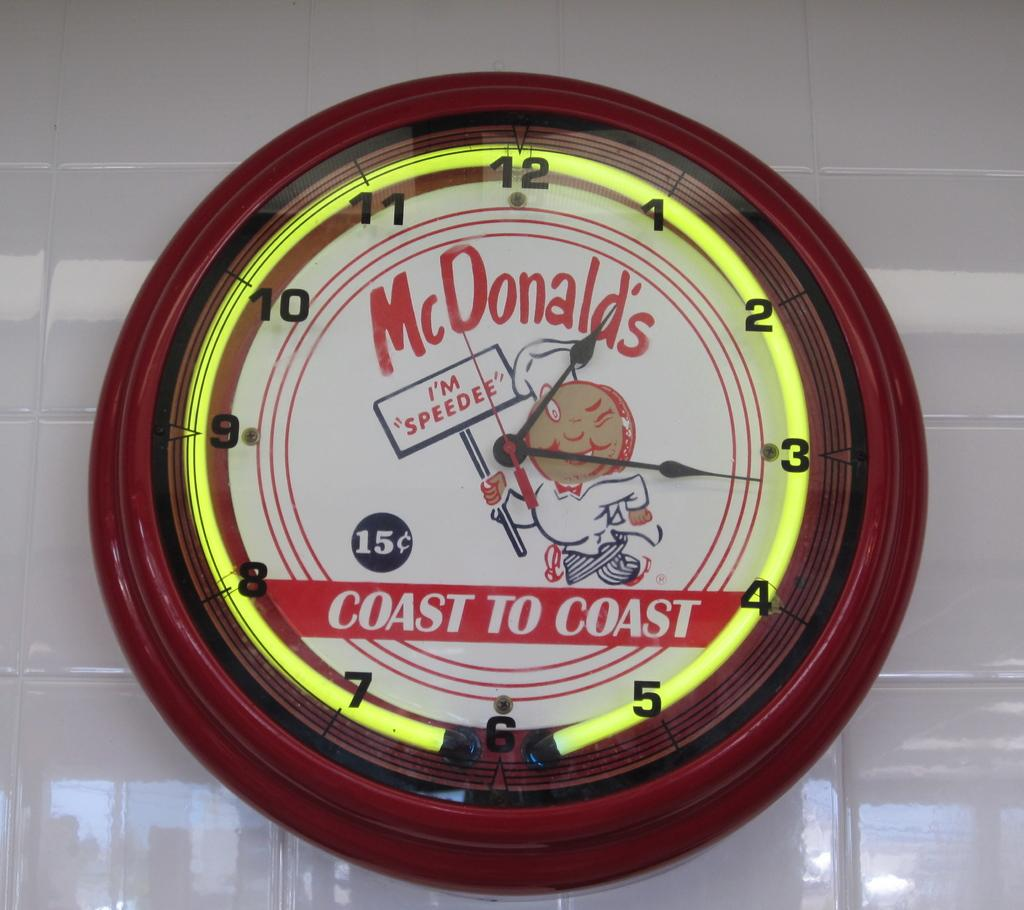<image>
Render a clear and concise summary of the photo. A McDonald's clock shows the time of 1:16. 